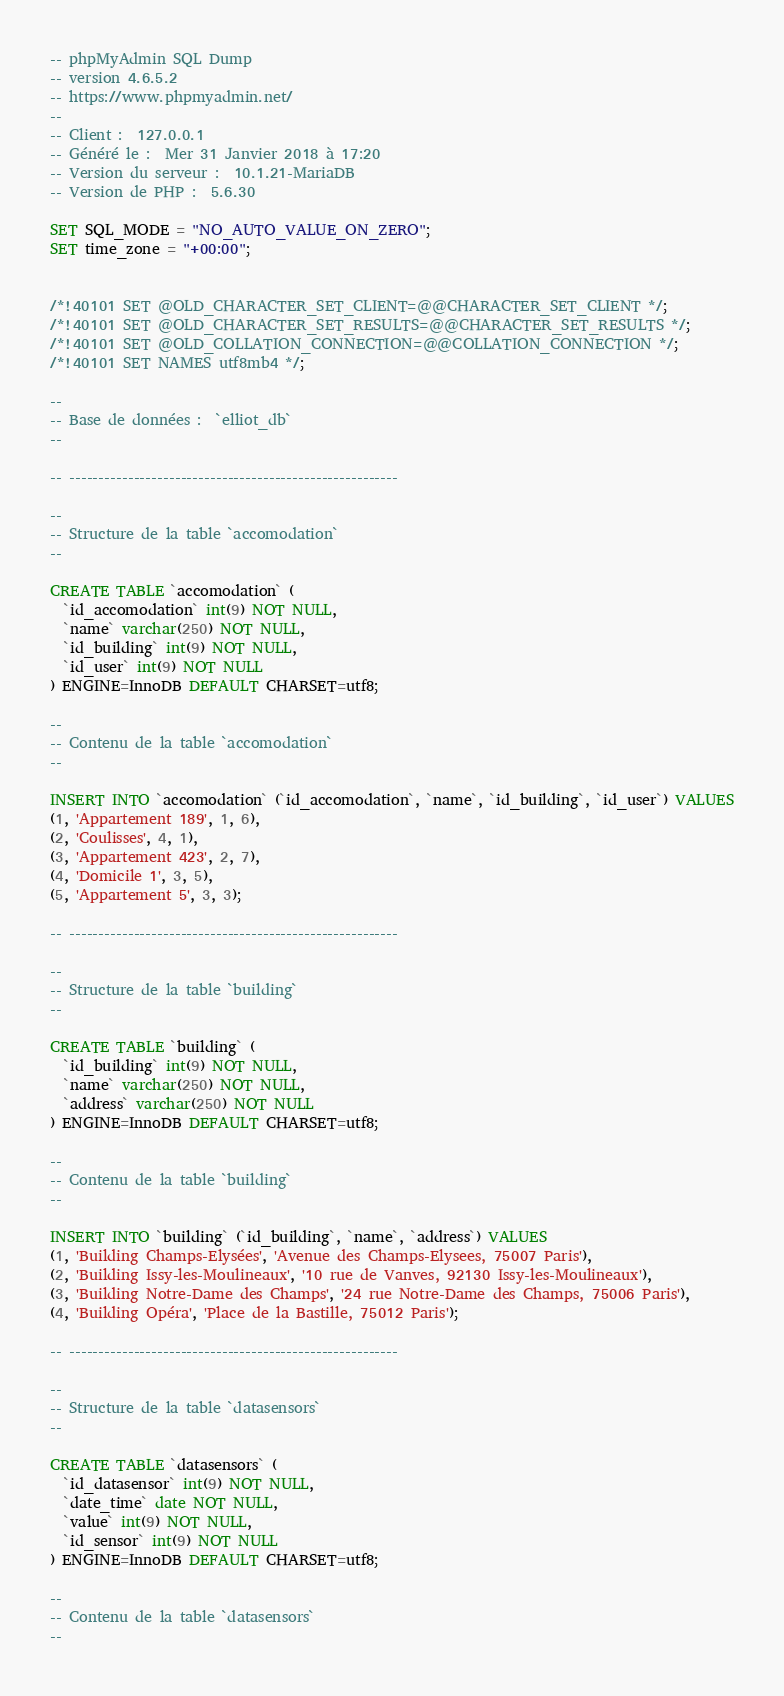Convert code to text. <code><loc_0><loc_0><loc_500><loc_500><_SQL_>-- phpMyAdmin SQL Dump
-- version 4.6.5.2
-- https://www.phpmyadmin.net/
--
-- Client :  127.0.0.1
-- Généré le :  Mer 31 Janvier 2018 à 17:20
-- Version du serveur :  10.1.21-MariaDB
-- Version de PHP :  5.6.30

SET SQL_MODE = "NO_AUTO_VALUE_ON_ZERO";
SET time_zone = "+00:00";


/*!40101 SET @OLD_CHARACTER_SET_CLIENT=@@CHARACTER_SET_CLIENT */;
/*!40101 SET @OLD_CHARACTER_SET_RESULTS=@@CHARACTER_SET_RESULTS */;
/*!40101 SET @OLD_COLLATION_CONNECTION=@@COLLATION_CONNECTION */;
/*!40101 SET NAMES utf8mb4 */;

--
-- Base de données :  `elliot_db`
--

-- --------------------------------------------------------

--
-- Structure de la table `accomodation`
--

CREATE TABLE `accomodation` (
  `id_accomodation` int(9) NOT NULL,
  `name` varchar(250) NOT NULL,
  `id_building` int(9) NOT NULL,
  `id_user` int(9) NOT NULL
) ENGINE=InnoDB DEFAULT CHARSET=utf8;

--
-- Contenu de la table `accomodation`
--

INSERT INTO `accomodation` (`id_accomodation`, `name`, `id_building`, `id_user`) VALUES
(1, 'Appartement 189', 1, 6),
(2, 'Coulisses', 4, 1),
(3, 'Appartement 423', 2, 7),
(4, 'Domicile 1', 3, 5),
(5, 'Appartement 5', 3, 3);

-- --------------------------------------------------------

--
-- Structure de la table `building`
--

CREATE TABLE `building` (
  `id_building` int(9) NOT NULL,
  `name` varchar(250) NOT NULL,
  `address` varchar(250) NOT NULL
) ENGINE=InnoDB DEFAULT CHARSET=utf8;

--
-- Contenu de la table `building`
--

INSERT INTO `building` (`id_building`, `name`, `address`) VALUES
(1, 'Building Champs-Elysées', 'Avenue des Champs-Elysees, 75007 Paris'),
(2, 'Building Issy-les-Moulineaux', '10 rue de Vanves, 92130 Issy-les-Moulineaux'),
(3, 'Building Notre-Dame des Champs', '24 rue Notre-Dame des Champs, 75006 Paris'),
(4, 'Building Opéra', 'Place de la Bastille, 75012 Paris');

-- --------------------------------------------------------

--
-- Structure de la table `datasensors`
--

CREATE TABLE `datasensors` (
  `id_datasensor` int(9) NOT NULL,
  `date_time` date NOT NULL,
  `value` int(9) NOT NULL,
  `id_sensor` int(9) NOT NULL
) ENGINE=InnoDB DEFAULT CHARSET=utf8;

--
-- Contenu de la table `datasensors`
--
</code> 